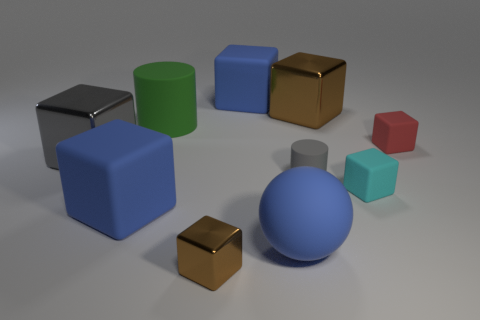Subtract all cyan blocks. How many blocks are left? 6 Subtract all blue matte blocks. How many blocks are left? 5 Subtract all blue cubes. Subtract all green cylinders. How many cubes are left? 5 Subtract all balls. How many objects are left? 9 Subtract all large green objects. Subtract all big metallic objects. How many objects are left? 7 Add 6 gray metal things. How many gray metal things are left? 7 Add 8 big cylinders. How many big cylinders exist? 9 Subtract 0 red balls. How many objects are left? 10 